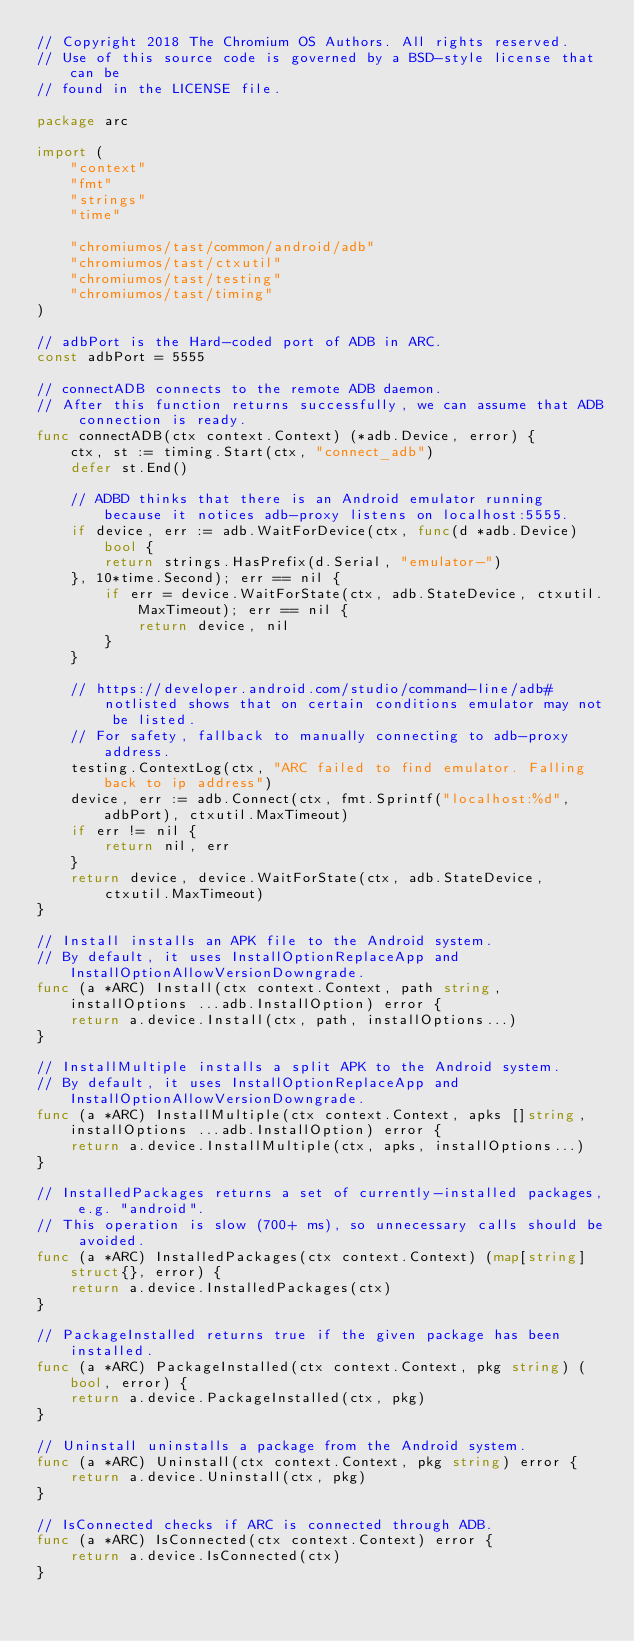Convert code to text. <code><loc_0><loc_0><loc_500><loc_500><_Go_>// Copyright 2018 The Chromium OS Authors. All rights reserved.
// Use of this source code is governed by a BSD-style license that can be
// found in the LICENSE file.

package arc

import (
	"context"
	"fmt"
	"strings"
	"time"

	"chromiumos/tast/common/android/adb"
	"chromiumos/tast/ctxutil"
	"chromiumos/tast/testing"
	"chromiumos/tast/timing"
)

// adbPort is the Hard-coded port of ADB in ARC.
const adbPort = 5555

// connectADB connects to the remote ADB daemon.
// After this function returns successfully, we can assume that ADB connection is ready.
func connectADB(ctx context.Context) (*adb.Device, error) {
	ctx, st := timing.Start(ctx, "connect_adb")
	defer st.End()

	// ADBD thinks that there is an Android emulator running because it notices adb-proxy listens on localhost:5555.
	if device, err := adb.WaitForDevice(ctx, func(d *adb.Device) bool {
		return strings.HasPrefix(d.Serial, "emulator-")
	}, 10*time.Second); err == nil {
		if err = device.WaitForState(ctx, adb.StateDevice, ctxutil.MaxTimeout); err == nil {
			return device, nil
		}
	}

	// https://developer.android.com/studio/command-line/adb#notlisted shows that on certain conditions emulator may not be listed.
	// For safety, fallback to manually connecting to adb-proxy address.
	testing.ContextLog(ctx, "ARC failed to find emulator. Falling back to ip address")
	device, err := adb.Connect(ctx, fmt.Sprintf("localhost:%d", adbPort), ctxutil.MaxTimeout)
	if err != nil {
		return nil, err
	}
	return device, device.WaitForState(ctx, adb.StateDevice, ctxutil.MaxTimeout)
}

// Install installs an APK file to the Android system.
// By default, it uses InstallOptionReplaceApp and InstallOptionAllowVersionDowngrade.
func (a *ARC) Install(ctx context.Context, path string, installOptions ...adb.InstallOption) error {
	return a.device.Install(ctx, path, installOptions...)
}

// InstallMultiple installs a split APK to the Android system.
// By default, it uses InstallOptionReplaceApp and InstallOptionAllowVersionDowngrade.
func (a *ARC) InstallMultiple(ctx context.Context, apks []string, installOptions ...adb.InstallOption) error {
	return a.device.InstallMultiple(ctx, apks, installOptions...)
}

// InstalledPackages returns a set of currently-installed packages, e.g. "android".
// This operation is slow (700+ ms), so unnecessary calls should be avoided.
func (a *ARC) InstalledPackages(ctx context.Context) (map[string]struct{}, error) {
	return a.device.InstalledPackages(ctx)
}

// PackageInstalled returns true if the given package has been installed.
func (a *ARC) PackageInstalled(ctx context.Context, pkg string) (bool, error) {
	return a.device.PackageInstalled(ctx, pkg)
}

// Uninstall uninstalls a package from the Android system.
func (a *ARC) Uninstall(ctx context.Context, pkg string) error {
	return a.device.Uninstall(ctx, pkg)
}

// IsConnected checks if ARC is connected through ADB.
func (a *ARC) IsConnected(ctx context.Context) error {
	return a.device.IsConnected(ctx)
}
</code> 